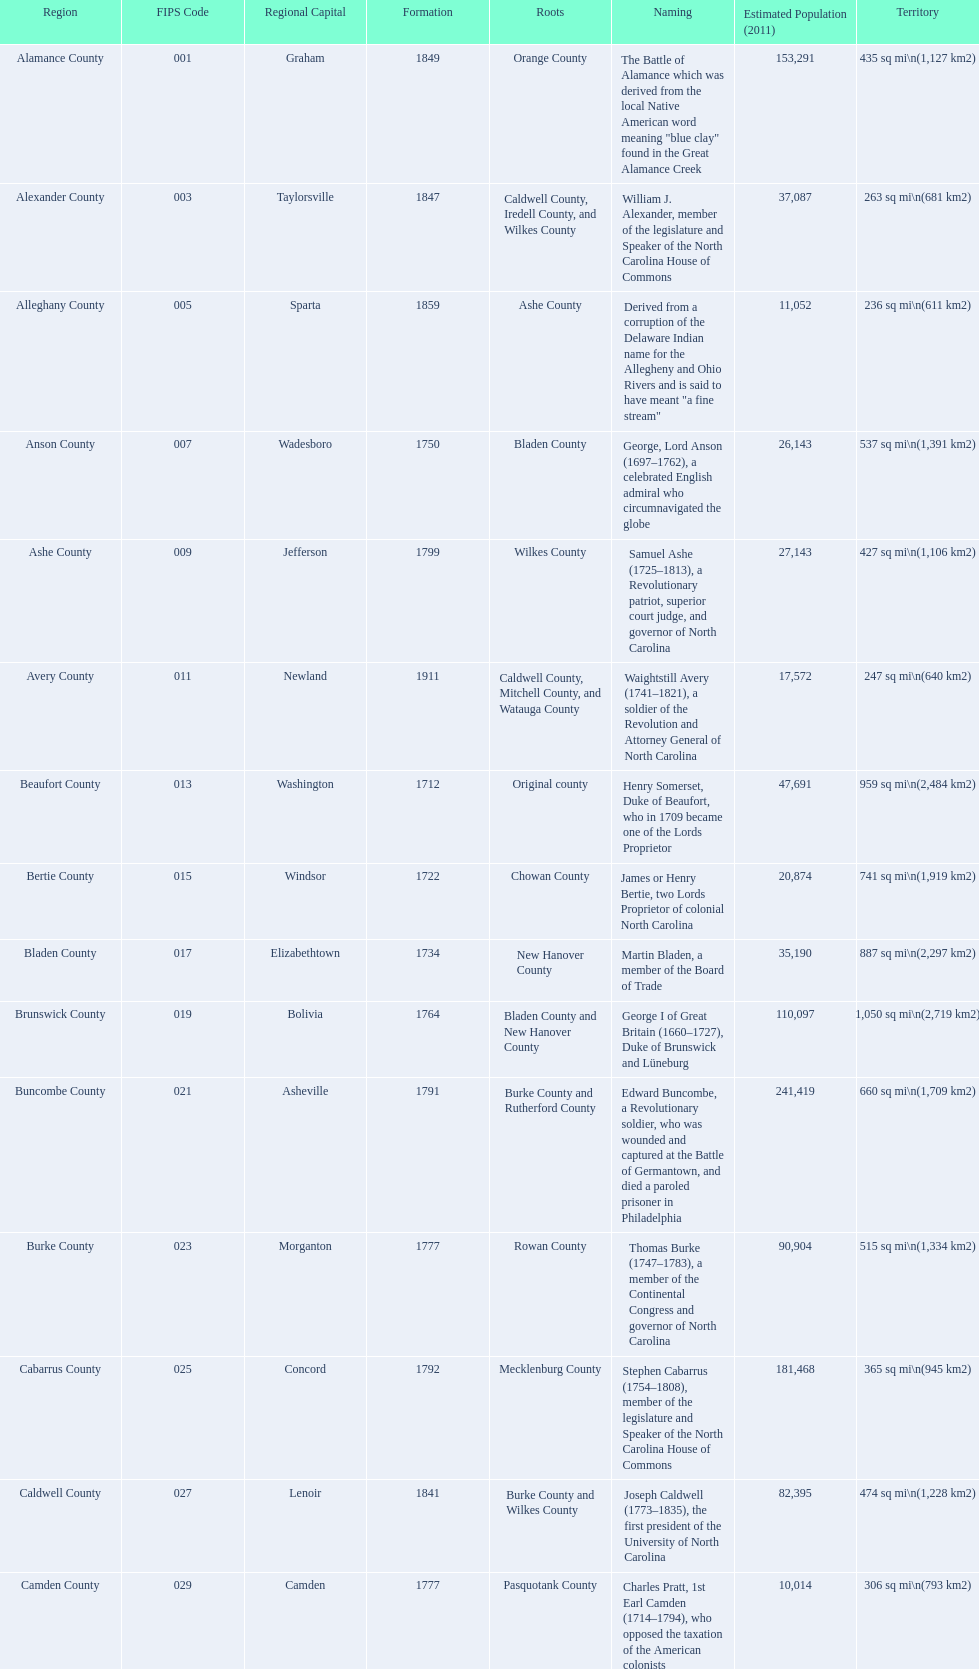Which is the only county with a name derived from a battle? Alamance County. 